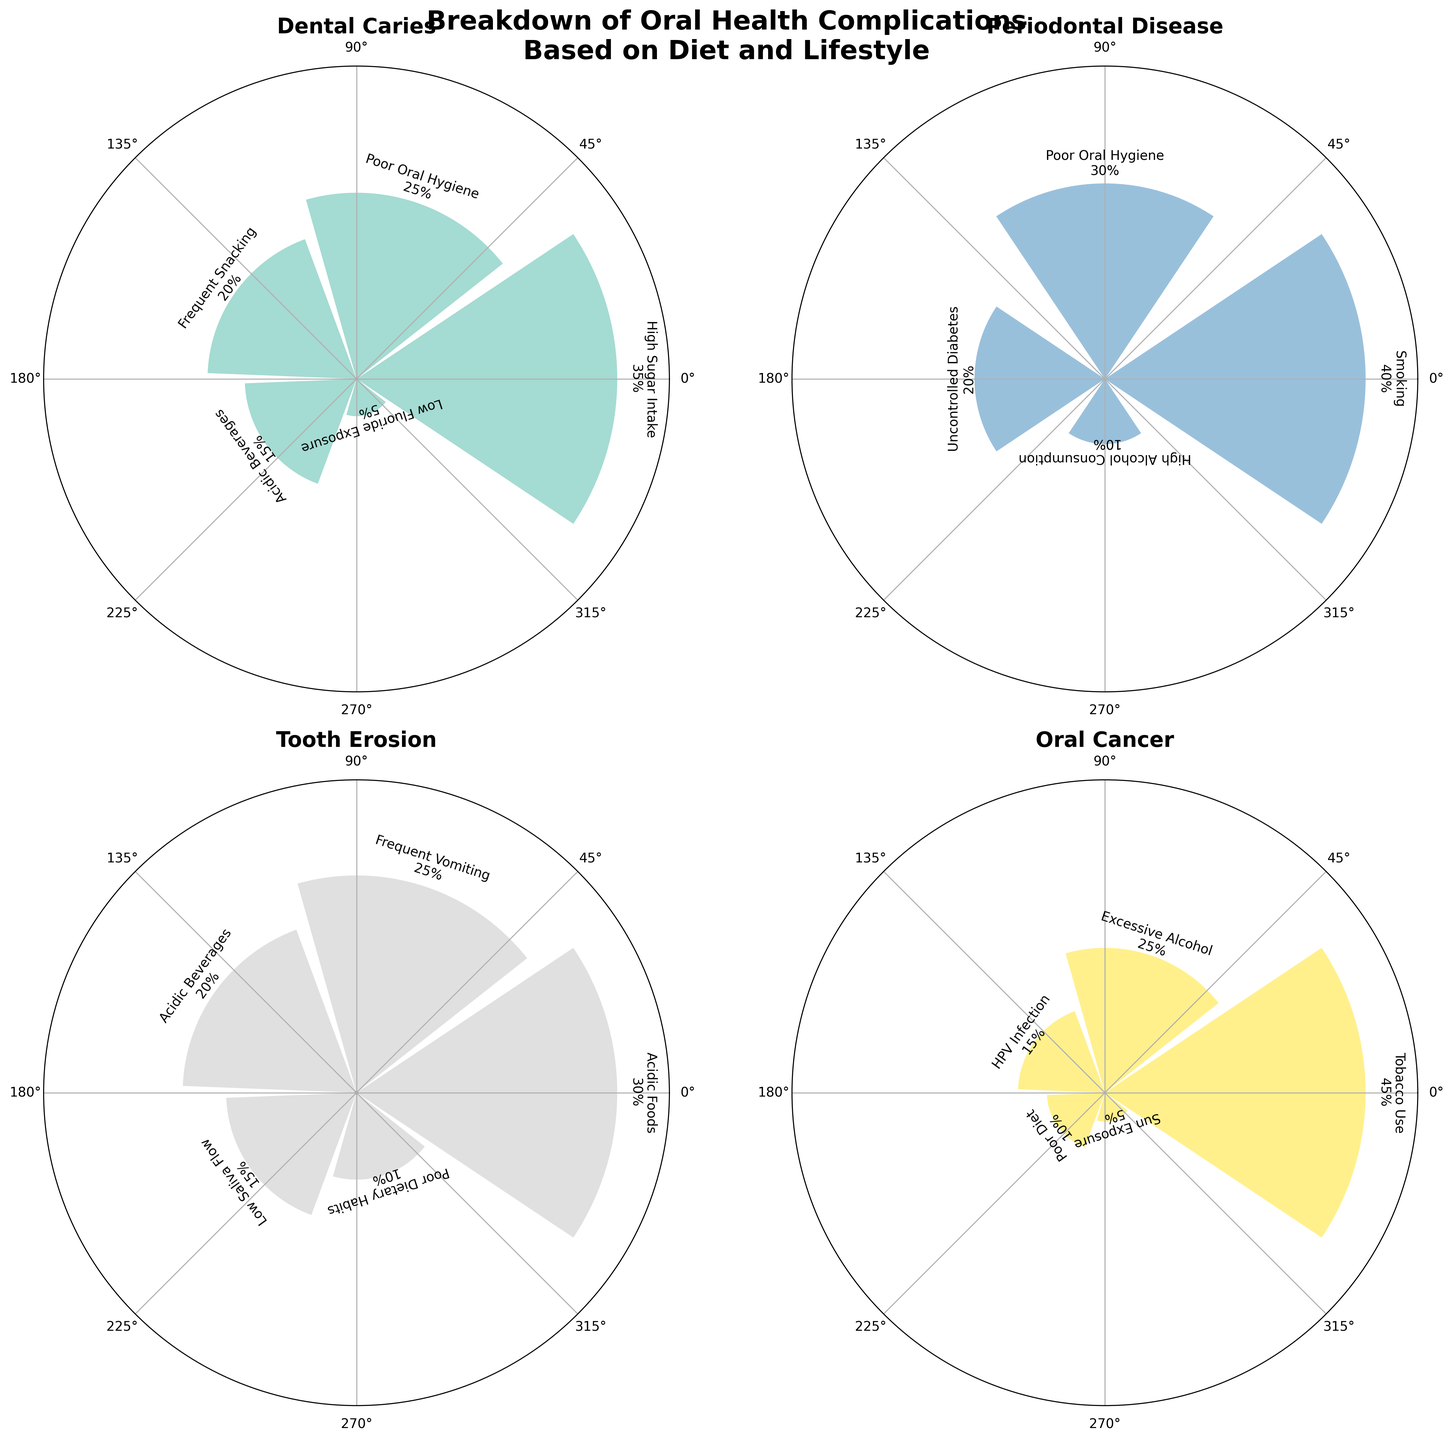What is the most common diet/lifestyle factor causing Dental Caries? Dental Caries has several contributing factors, each represented by segments with different sizes in its respective subplot. The largest segment is for High Sugar Intake, which covers 35% of the cases.
Answer: High Sugar Intake Which complication is primarily caused by Smoking? Each subplot corresponds to a different complication, and the one for Periodontal Disease has the Smoking segment, which is largest at 40%.
Answer: Periodontal Disease What percentage of Tooth Erosion cases are due to Acidic Foods? Looking at the Tooth Erosion subplot, there is a segment labeled Acidic Foods which occupies 30%.
Answer: 30% How does the percentage of Poor Oral Hygiene in contributing to Periodontal Disease compare to its percentage in contributing to Dental Caries? First, find the Poor Oral Hygiene segment in both the Periodontal Disease and Dental Caries subplots. It's 30% for Periodontal Disease and 25% for Dental Caries.
Answer: Larger in Periodontal Disease Combine the percentages of contributors to Oral Cancer, excluding the top factor. What is the resulting percentage? The top factor for Oral Cancer is Tobacco Use at 45%. The other contributors are Excessive Alcohol (25%), HPV Infection (15%), Poor Diet (10%), and Sun Exposure (5%). Summing these gives 25% + 15% + 10% + 5% = 55%.
Answer: 55% Which complication has the smallest single factor contribution and what is that factor? Looking at the smallest segments in each subplot, Sun Exposure in Oral Cancer is the smallest at 5%.
Answer: Oral Cancer (Sun Exposure) Rank the complications based on the variety of diet/lifestyle factors provided in their subplots. The number of segments (factors) in each subplot indicates variety: Dental Caries (5), Periodontal Disease (4), Tooth Erosion (5), and Oral Cancer (5). Thus, Dental Caries, Tooth Erosion, and Oral Cancer each have 5, and Periodontal Disease has 4.
Answer: 1. Dental Caries/Tooth Erosion/Oral Cancer (tied), 2. Periodontal Disease Which complication has the highest percentage contribution from a single factor, and what is that percentage? By looking at the largest segments across all subplots, Tobacco Use in Oral Cancer is the highest at 45%.
Answer: Oral Cancer (45%) What are the two main factors of Tooth Erosion and their combined contribution percentage? Tooth Erosion subplot shows main factors: Acidic Foods (30%) and Frequent Vomiting (25%). Therefore, combining these: 30% + 25% = 55%.
Answer: Acidic Foods and Frequent Vomiting (55%) If one was to reduce High Sugar Intake and Acidic Beverages to zero, what would be the new percentage of Dental Caries from the remaining factors? High Sugar Intake and Acidic Beverages contribute 35% and 15% respectively. If these are removed: 100% - 35% - 15% = 50%. The remaining factors contribute: Poor Oral Hygiene (25%), Frequent Snacking (20%), and Low Fluoride Exposure (5%). So, Dental Caries would be reduced to 25% + 20% + 5% = 50%.
Answer: 50% 